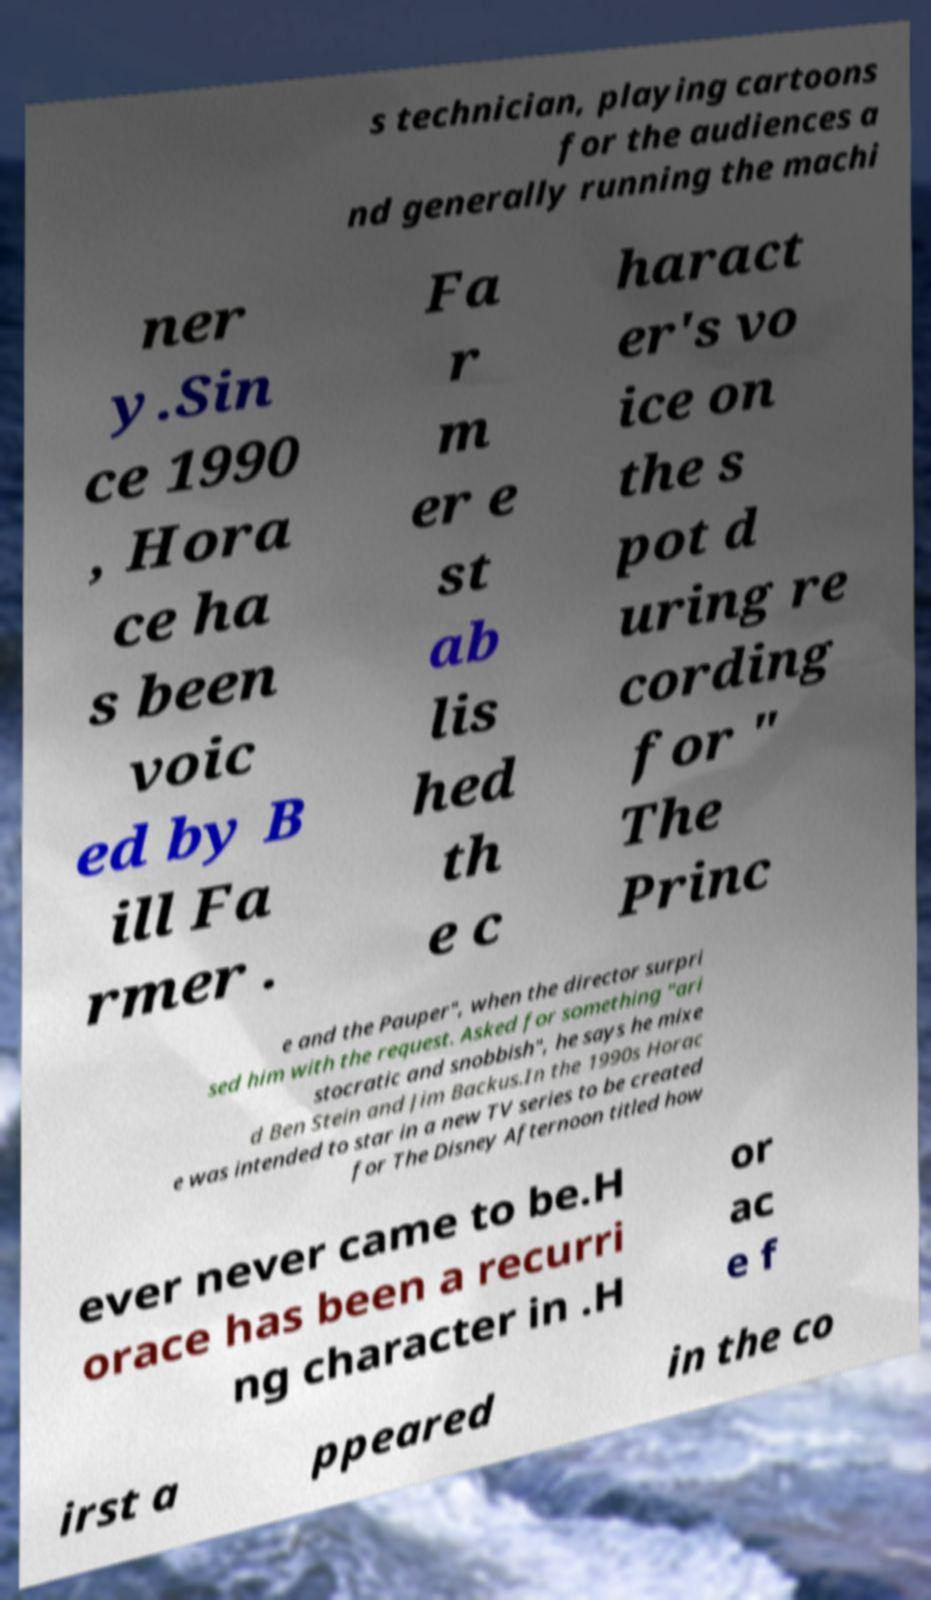What messages or text are displayed in this image? I need them in a readable, typed format. s technician, playing cartoons for the audiences a nd generally running the machi ner y.Sin ce 1990 , Hora ce ha s been voic ed by B ill Fa rmer . Fa r m er e st ab lis hed th e c haract er's vo ice on the s pot d uring re cording for " The Princ e and the Pauper", when the director surpri sed him with the request. Asked for something "ari stocratic and snobbish", he says he mixe d Ben Stein and Jim Backus.In the 1990s Horac e was intended to star in a new TV series to be created for The Disney Afternoon titled how ever never came to be.H orace has been a recurri ng character in .H or ac e f irst a ppeared in the co 